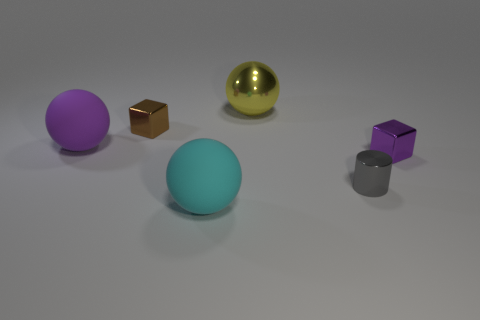There is a ball that is in front of the tiny block that is on the right side of the tiny shiny cylinder; what is its material?
Give a very brief answer. Rubber. What is the big thing that is to the left of the big cyan rubber object made of?
Provide a succinct answer. Rubber. Do the big yellow thing and the purple object to the left of the big yellow shiny ball have the same shape?
Make the answer very short. Yes. The big object that is on the right side of the tiny brown cube and to the left of the yellow metallic thing is made of what material?
Your response must be concise. Rubber. There is a rubber ball that is the same size as the cyan object; what color is it?
Your answer should be compact. Purple. Is the material of the tiny cylinder the same as the ball in front of the tiny gray thing?
Offer a very short reply. No. How many other things are there of the same size as the cyan sphere?
Ensure brevity in your answer.  2. There is a purple object that is left of the rubber thing that is in front of the cylinder; is there a cylinder to the right of it?
Your answer should be compact. Yes. The purple shiny cube is what size?
Provide a succinct answer. Small. What size is the rubber object behind the small metal cylinder?
Your answer should be very brief. Large. 